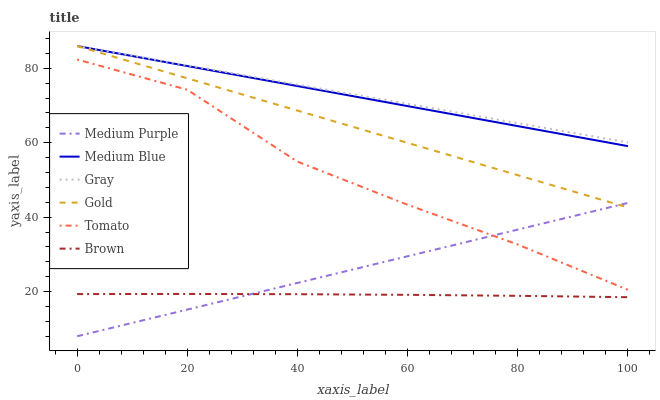Does Brown have the minimum area under the curve?
Answer yes or no. Yes. Does Gray have the maximum area under the curve?
Answer yes or no. Yes. Does Gold have the minimum area under the curve?
Answer yes or no. No. Does Gold have the maximum area under the curve?
Answer yes or no. No. Is Medium Purple the smoothest?
Answer yes or no. Yes. Is Tomato the roughest?
Answer yes or no. Yes. Is Gray the smoothest?
Answer yes or no. No. Is Gray the roughest?
Answer yes or no. No. Does Gold have the lowest value?
Answer yes or no. No. Does Medium Blue have the highest value?
Answer yes or no. Yes. Does Brown have the highest value?
Answer yes or no. No. Is Brown less than Gray?
Answer yes or no. Yes. Is Medium Blue greater than Tomato?
Answer yes or no. Yes. Does Medium Blue intersect Gray?
Answer yes or no. Yes. Is Medium Blue less than Gray?
Answer yes or no. No. Is Medium Blue greater than Gray?
Answer yes or no. No. Does Brown intersect Gray?
Answer yes or no. No. 